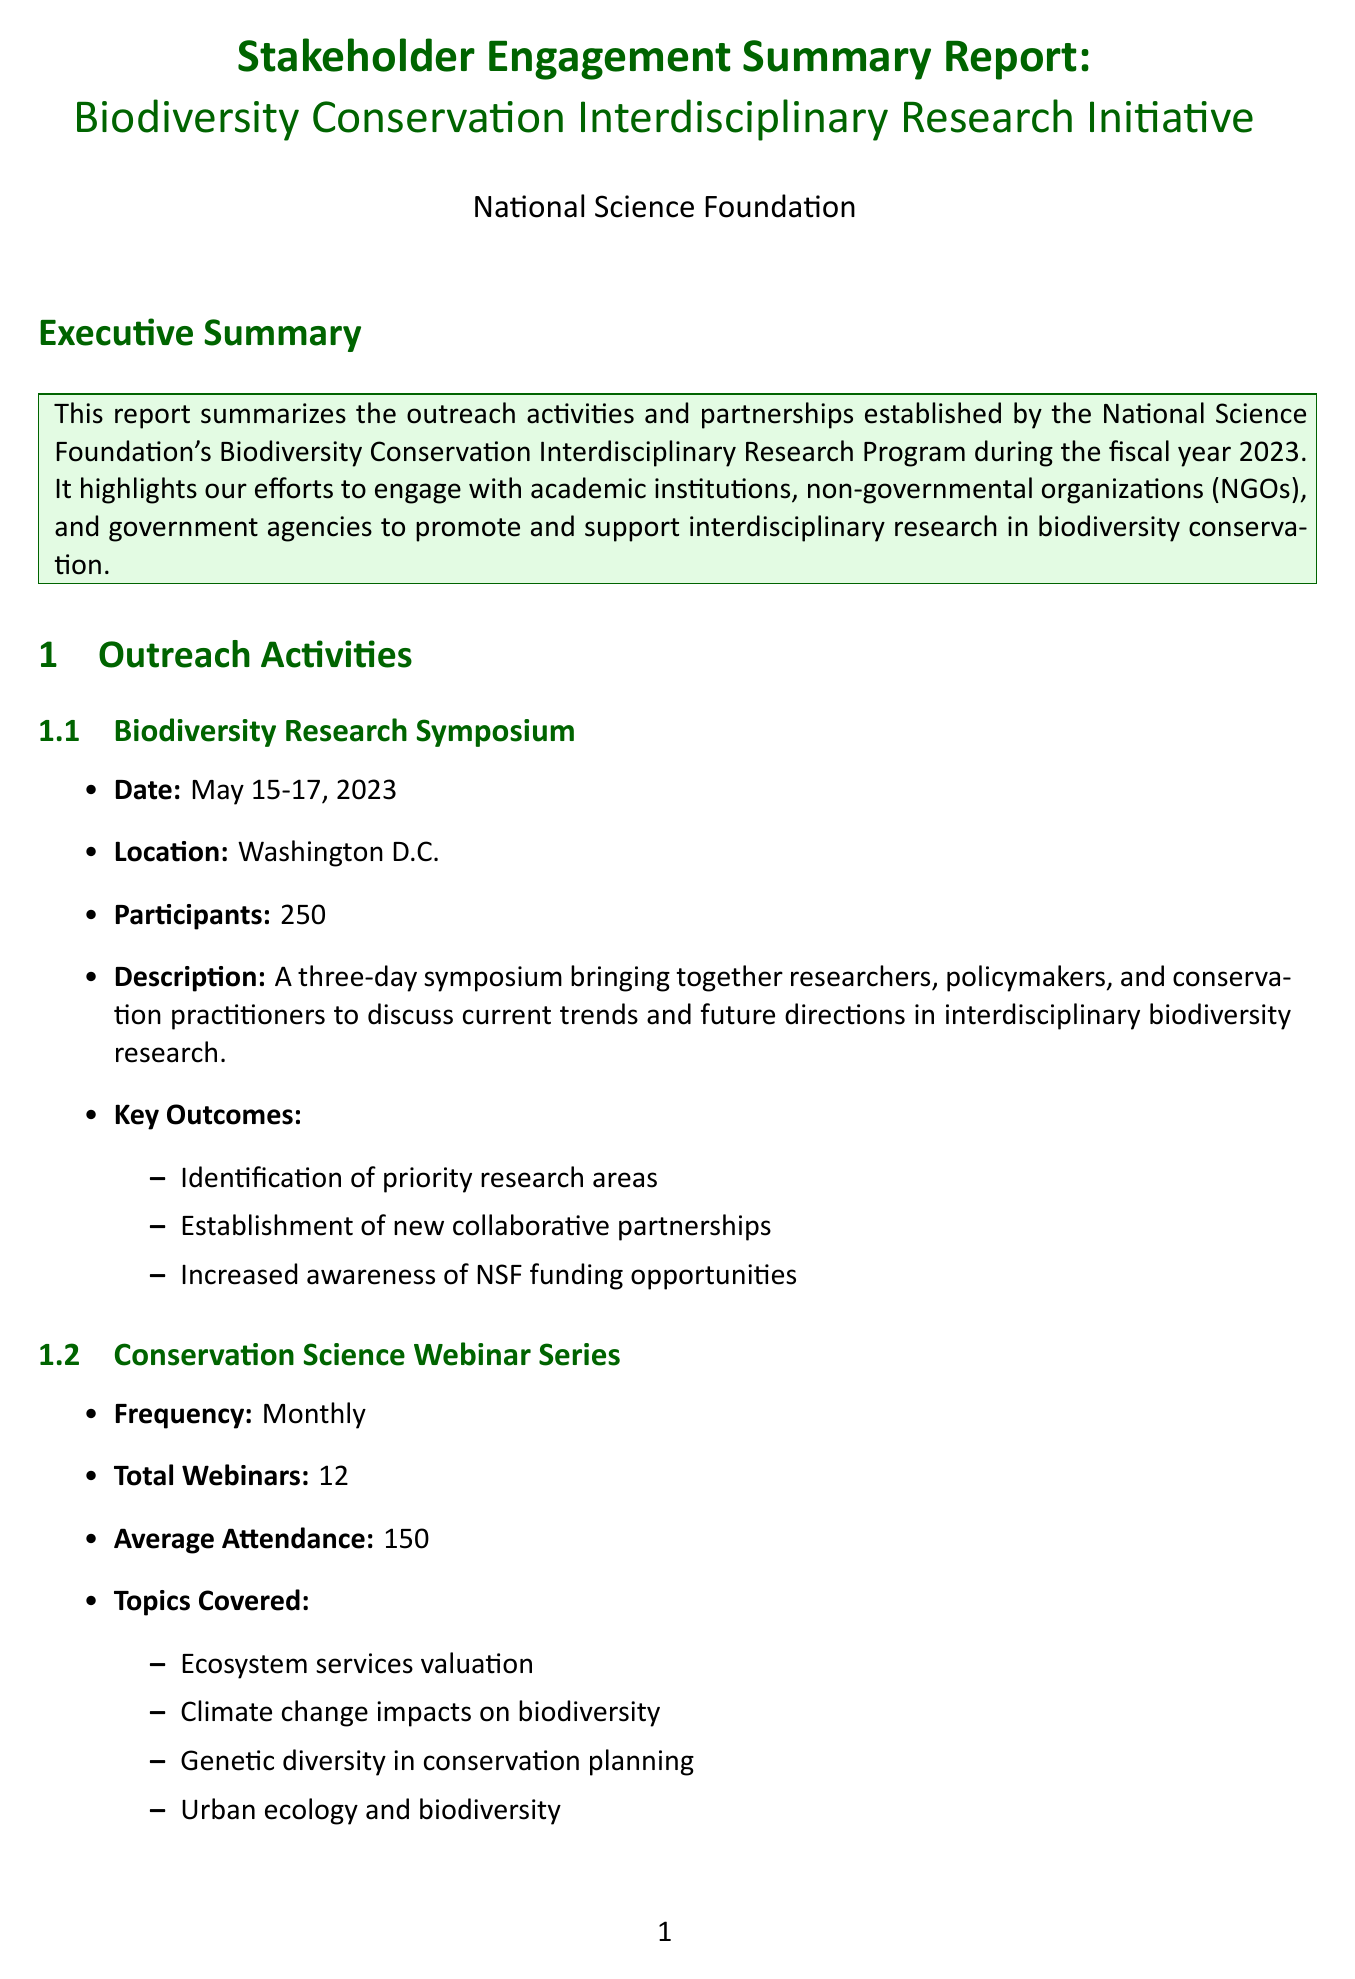What was the date of the Biodiversity Research Symposium? The date for the symposium is clearly mentioned in the outreach activities section as May 15-17, 2023.
Answer: May 15-17, 2023 How many participants attended the Early Career Researchers Workshop? The number of participants is listed in the workshop details, which is 75.
Answer: 75 What organization is collaborating with the NSF on the project 'Collaborative Database for Global Biodiversity Threats'? The NGO partnership section specifies that the World Wildlife Fund (WWF) is the organization involved in this project.
Answer: World Wildlife Fund (WWF) How many interdisciplinary research projects were funded by NOAA? The government agency collaborations mention that NOAA funded 8 interdisciplinary research projects.
Answer: 8 What is the total number of webinars conducted in the Conservation Science Webinar Series? The number of webinars is indicated in the series details, and it states a total of 12 webinars.
Answer: 12 Which academic institution is associated with the project 'AI-Driven Biodiversity Monitoring in Tropical Forests'? The academic partnerships section identifies the University of California, Berkeley as the institution for this project.
Answer: University of California, Berkeley What key outcome was achieved during the Biodiversity Research Symposium? The key outcomes listed include the identification of priority research areas, which reflects significant accomplishments from the symposium.
Answer: Identification of priority research areas What are the key challenges noted in the report? The report lists challenges including balancing diverse stakeholder interests and priorities, which highlights the complexities faced during engagement efforts.
Answer: Balancing diverse stakeholder interests and priorities What is the duration of the project led by Dr. Marcus Johnson at Duke University? The duration of the project mentioned in the academic partnerships section is specifically described as 2 years.
Answer: 2 years 